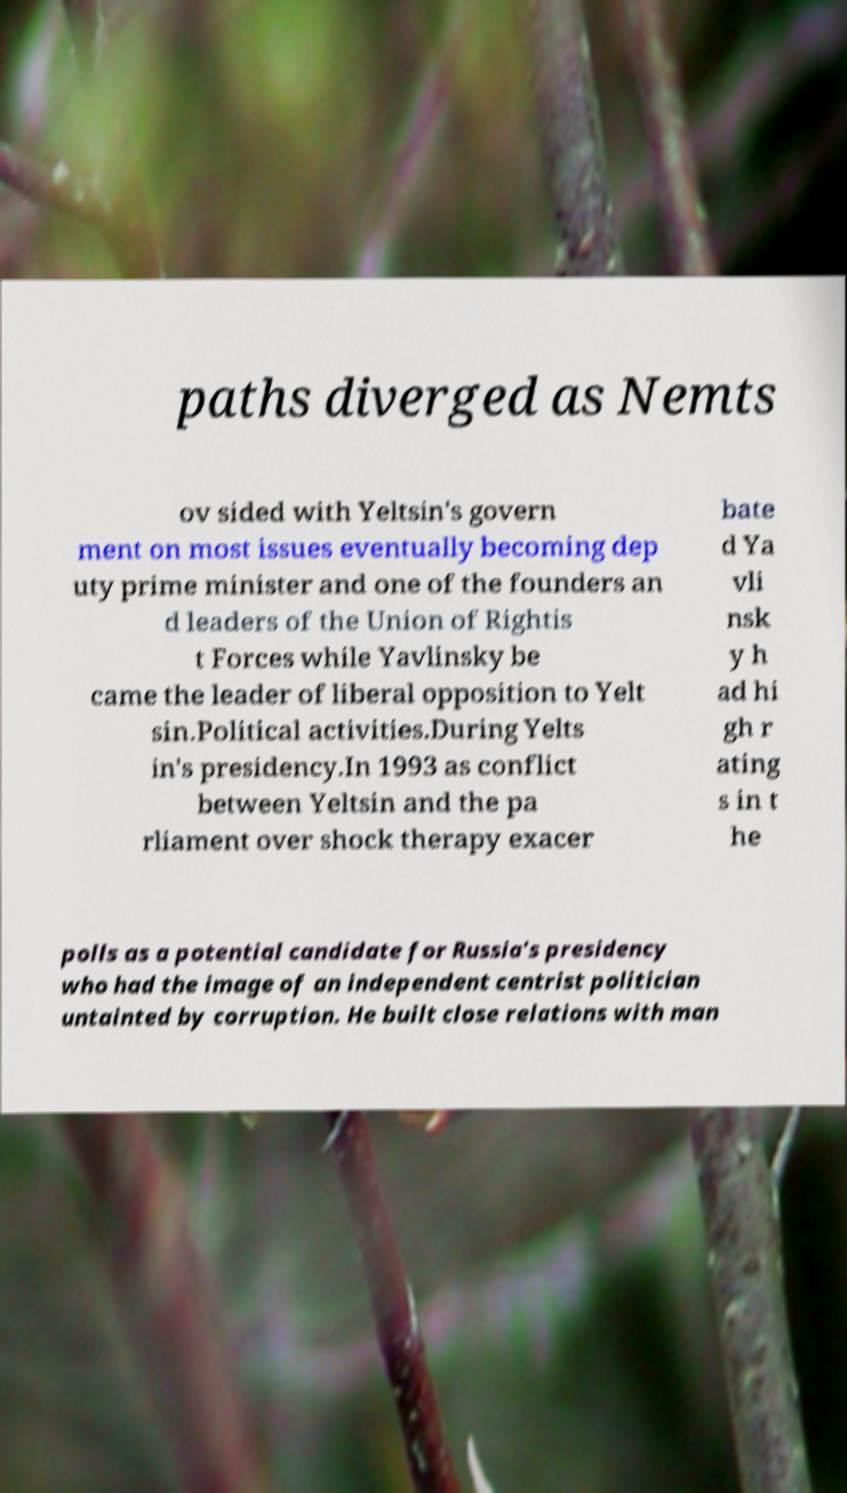Please identify and transcribe the text found in this image. paths diverged as Nemts ov sided with Yeltsin's govern ment on most issues eventually becoming dep uty prime minister and one of the founders an d leaders of the Union of Rightis t Forces while Yavlinsky be came the leader of liberal opposition to Yelt sin.Political activities.During Yelts in's presidency.In 1993 as conflict between Yeltsin and the pa rliament over shock therapy exacer bate d Ya vli nsk y h ad hi gh r ating s in t he polls as a potential candidate for Russia's presidency who had the image of an independent centrist politician untainted by corruption. He built close relations with man 